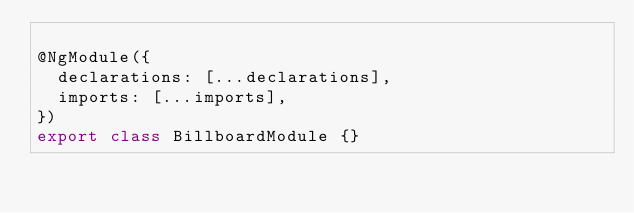Convert code to text. <code><loc_0><loc_0><loc_500><loc_500><_TypeScript_>
@NgModule({
  declarations: [...declarations],
  imports: [...imports],
})
export class BillboardModule {}
</code> 